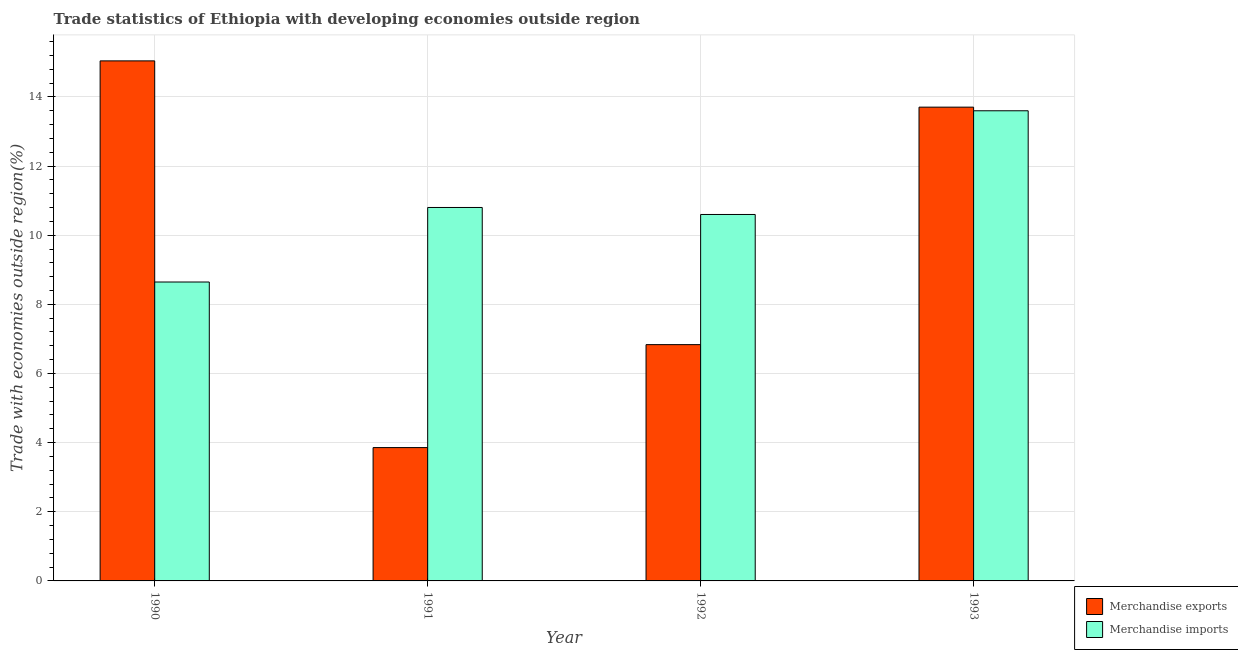How many different coloured bars are there?
Your answer should be compact. 2. How many groups of bars are there?
Your answer should be very brief. 4. Are the number of bars per tick equal to the number of legend labels?
Provide a short and direct response. Yes. Are the number of bars on each tick of the X-axis equal?
Your answer should be compact. Yes. What is the merchandise exports in 1990?
Offer a very short reply. 15.04. Across all years, what is the maximum merchandise exports?
Give a very brief answer. 15.04. Across all years, what is the minimum merchandise exports?
Give a very brief answer. 3.86. In which year was the merchandise exports maximum?
Your response must be concise. 1990. In which year was the merchandise imports minimum?
Your answer should be very brief. 1990. What is the total merchandise imports in the graph?
Offer a very short reply. 43.64. What is the difference between the merchandise imports in 1990 and that in 1991?
Ensure brevity in your answer.  -2.16. What is the difference between the merchandise exports in 1990 and the merchandise imports in 1991?
Give a very brief answer. 11.18. What is the average merchandise exports per year?
Your answer should be very brief. 9.86. What is the ratio of the merchandise imports in 1990 to that in 1992?
Your answer should be very brief. 0.82. Is the merchandise imports in 1990 less than that in 1993?
Offer a very short reply. Yes. What is the difference between the highest and the second highest merchandise exports?
Provide a succinct answer. 1.34. What is the difference between the highest and the lowest merchandise imports?
Provide a short and direct response. 4.95. Is the sum of the merchandise exports in 1991 and 1992 greater than the maximum merchandise imports across all years?
Your answer should be compact. No. What does the 2nd bar from the right in 1990 represents?
Your response must be concise. Merchandise exports. Are all the bars in the graph horizontal?
Offer a terse response. No. How many years are there in the graph?
Your response must be concise. 4. What is the difference between two consecutive major ticks on the Y-axis?
Your answer should be compact. 2. Are the values on the major ticks of Y-axis written in scientific E-notation?
Ensure brevity in your answer.  No. Does the graph contain any zero values?
Your answer should be compact. No. Does the graph contain grids?
Offer a very short reply. Yes. Where does the legend appear in the graph?
Ensure brevity in your answer.  Bottom right. How are the legend labels stacked?
Offer a terse response. Vertical. What is the title of the graph?
Keep it short and to the point. Trade statistics of Ethiopia with developing economies outside region. Does "Non-resident workers" appear as one of the legend labels in the graph?
Give a very brief answer. No. What is the label or title of the Y-axis?
Offer a terse response. Trade with economies outside region(%). What is the Trade with economies outside region(%) of Merchandise exports in 1990?
Make the answer very short. 15.04. What is the Trade with economies outside region(%) in Merchandise imports in 1990?
Provide a short and direct response. 8.65. What is the Trade with economies outside region(%) of Merchandise exports in 1991?
Provide a succinct answer. 3.86. What is the Trade with economies outside region(%) of Merchandise imports in 1991?
Give a very brief answer. 10.8. What is the Trade with economies outside region(%) in Merchandise exports in 1992?
Your answer should be very brief. 6.83. What is the Trade with economies outside region(%) in Merchandise imports in 1992?
Keep it short and to the point. 10.6. What is the Trade with economies outside region(%) in Merchandise exports in 1993?
Keep it short and to the point. 13.7. What is the Trade with economies outside region(%) of Merchandise imports in 1993?
Provide a short and direct response. 13.6. Across all years, what is the maximum Trade with economies outside region(%) of Merchandise exports?
Offer a terse response. 15.04. Across all years, what is the maximum Trade with economies outside region(%) of Merchandise imports?
Your answer should be compact. 13.6. Across all years, what is the minimum Trade with economies outside region(%) in Merchandise exports?
Give a very brief answer. 3.86. Across all years, what is the minimum Trade with economies outside region(%) of Merchandise imports?
Provide a short and direct response. 8.65. What is the total Trade with economies outside region(%) of Merchandise exports in the graph?
Provide a succinct answer. 39.43. What is the total Trade with economies outside region(%) of Merchandise imports in the graph?
Keep it short and to the point. 43.64. What is the difference between the Trade with economies outside region(%) of Merchandise exports in 1990 and that in 1991?
Keep it short and to the point. 11.18. What is the difference between the Trade with economies outside region(%) of Merchandise imports in 1990 and that in 1991?
Provide a short and direct response. -2.16. What is the difference between the Trade with economies outside region(%) in Merchandise exports in 1990 and that in 1992?
Offer a very short reply. 8.21. What is the difference between the Trade with economies outside region(%) of Merchandise imports in 1990 and that in 1992?
Provide a succinct answer. -1.95. What is the difference between the Trade with economies outside region(%) of Merchandise exports in 1990 and that in 1993?
Give a very brief answer. 1.34. What is the difference between the Trade with economies outside region(%) in Merchandise imports in 1990 and that in 1993?
Give a very brief answer. -4.95. What is the difference between the Trade with economies outside region(%) in Merchandise exports in 1991 and that in 1992?
Your answer should be very brief. -2.98. What is the difference between the Trade with economies outside region(%) of Merchandise imports in 1991 and that in 1992?
Your response must be concise. 0.2. What is the difference between the Trade with economies outside region(%) of Merchandise exports in 1991 and that in 1993?
Keep it short and to the point. -9.85. What is the difference between the Trade with economies outside region(%) in Merchandise imports in 1991 and that in 1993?
Make the answer very short. -2.8. What is the difference between the Trade with economies outside region(%) in Merchandise exports in 1992 and that in 1993?
Your response must be concise. -6.87. What is the difference between the Trade with economies outside region(%) of Merchandise imports in 1992 and that in 1993?
Your answer should be very brief. -3. What is the difference between the Trade with economies outside region(%) in Merchandise exports in 1990 and the Trade with economies outside region(%) in Merchandise imports in 1991?
Make the answer very short. 4.24. What is the difference between the Trade with economies outside region(%) in Merchandise exports in 1990 and the Trade with economies outside region(%) in Merchandise imports in 1992?
Your response must be concise. 4.44. What is the difference between the Trade with economies outside region(%) of Merchandise exports in 1990 and the Trade with economies outside region(%) of Merchandise imports in 1993?
Ensure brevity in your answer.  1.44. What is the difference between the Trade with economies outside region(%) in Merchandise exports in 1991 and the Trade with economies outside region(%) in Merchandise imports in 1992?
Offer a very short reply. -6.74. What is the difference between the Trade with economies outside region(%) in Merchandise exports in 1991 and the Trade with economies outside region(%) in Merchandise imports in 1993?
Provide a short and direct response. -9.74. What is the difference between the Trade with economies outside region(%) of Merchandise exports in 1992 and the Trade with economies outside region(%) of Merchandise imports in 1993?
Keep it short and to the point. -6.76. What is the average Trade with economies outside region(%) of Merchandise exports per year?
Provide a succinct answer. 9.86. What is the average Trade with economies outside region(%) of Merchandise imports per year?
Your response must be concise. 10.91. In the year 1990, what is the difference between the Trade with economies outside region(%) of Merchandise exports and Trade with economies outside region(%) of Merchandise imports?
Ensure brevity in your answer.  6.4. In the year 1991, what is the difference between the Trade with economies outside region(%) in Merchandise exports and Trade with economies outside region(%) in Merchandise imports?
Your response must be concise. -6.94. In the year 1992, what is the difference between the Trade with economies outside region(%) in Merchandise exports and Trade with economies outside region(%) in Merchandise imports?
Offer a very short reply. -3.76. In the year 1993, what is the difference between the Trade with economies outside region(%) in Merchandise exports and Trade with economies outside region(%) in Merchandise imports?
Give a very brief answer. 0.1. What is the ratio of the Trade with economies outside region(%) in Merchandise exports in 1990 to that in 1991?
Provide a short and direct response. 3.9. What is the ratio of the Trade with economies outside region(%) in Merchandise imports in 1990 to that in 1991?
Offer a terse response. 0.8. What is the ratio of the Trade with economies outside region(%) in Merchandise exports in 1990 to that in 1992?
Keep it short and to the point. 2.2. What is the ratio of the Trade with economies outside region(%) in Merchandise imports in 1990 to that in 1992?
Your answer should be compact. 0.82. What is the ratio of the Trade with economies outside region(%) in Merchandise exports in 1990 to that in 1993?
Give a very brief answer. 1.1. What is the ratio of the Trade with economies outside region(%) in Merchandise imports in 1990 to that in 1993?
Offer a terse response. 0.64. What is the ratio of the Trade with economies outside region(%) of Merchandise exports in 1991 to that in 1992?
Your answer should be very brief. 0.56. What is the ratio of the Trade with economies outside region(%) of Merchandise imports in 1991 to that in 1992?
Make the answer very short. 1.02. What is the ratio of the Trade with economies outside region(%) of Merchandise exports in 1991 to that in 1993?
Your answer should be compact. 0.28. What is the ratio of the Trade with economies outside region(%) of Merchandise imports in 1991 to that in 1993?
Keep it short and to the point. 0.79. What is the ratio of the Trade with economies outside region(%) of Merchandise exports in 1992 to that in 1993?
Give a very brief answer. 0.5. What is the ratio of the Trade with economies outside region(%) in Merchandise imports in 1992 to that in 1993?
Your answer should be compact. 0.78. What is the difference between the highest and the second highest Trade with economies outside region(%) of Merchandise exports?
Keep it short and to the point. 1.34. What is the difference between the highest and the second highest Trade with economies outside region(%) of Merchandise imports?
Give a very brief answer. 2.8. What is the difference between the highest and the lowest Trade with economies outside region(%) in Merchandise exports?
Your answer should be very brief. 11.18. What is the difference between the highest and the lowest Trade with economies outside region(%) of Merchandise imports?
Your answer should be compact. 4.95. 